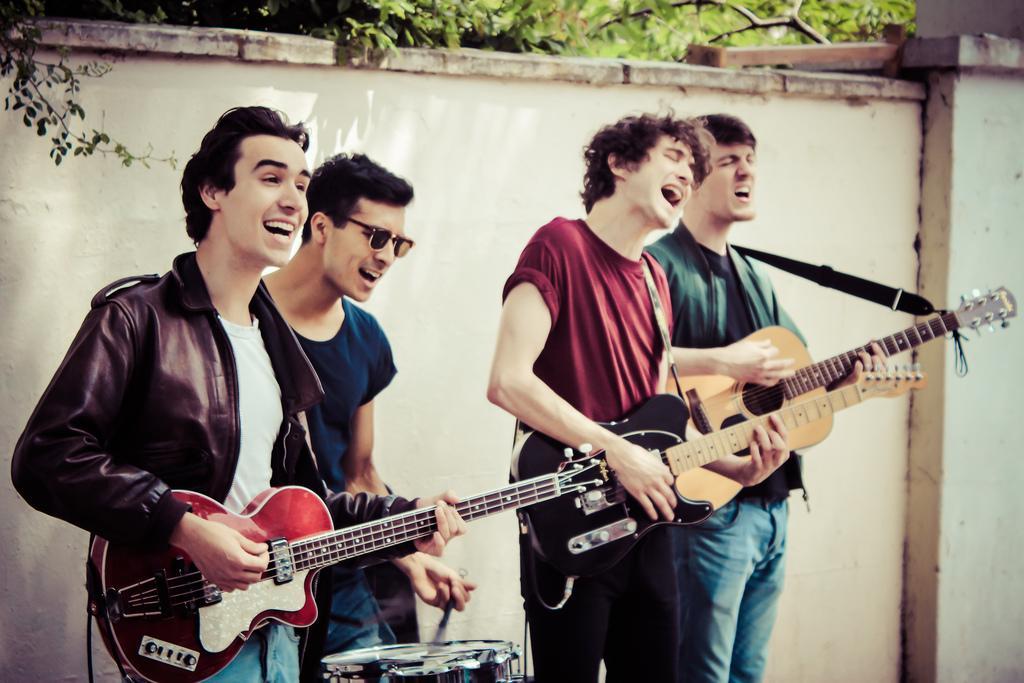Could you give a brief overview of what you see in this image? This picture outside on a sunny day. Four people are standing. In them three people are playing guitars and one is playing drums. Backside of them there is a wall and back to it there are some trees. Person who is wearing blue shirt is wearing goggles. Beside to him is wearing red shirt and black pant. 